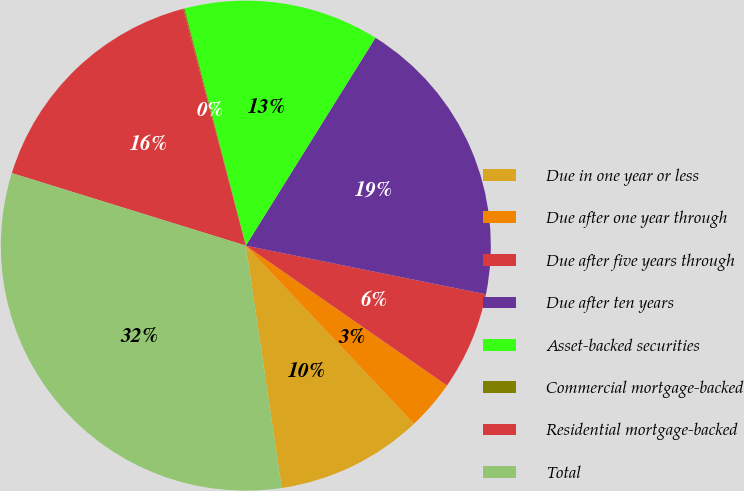<chart> <loc_0><loc_0><loc_500><loc_500><pie_chart><fcel>Due in one year or less<fcel>Due after one year through<fcel>Due after five years through<fcel>Due after ten years<fcel>Asset-backed securities<fcel>Commercial mortgage-backed<fcel>Residential mortgage-backed<fcel>Total<nl><fcel>9.7%<fcel>3.29%<fcel>6.49%<fcel>19.31%<fcel>12.9%<fcel>0.08%<fcel>16.11%<fcel>32.13%<nl></chart> 